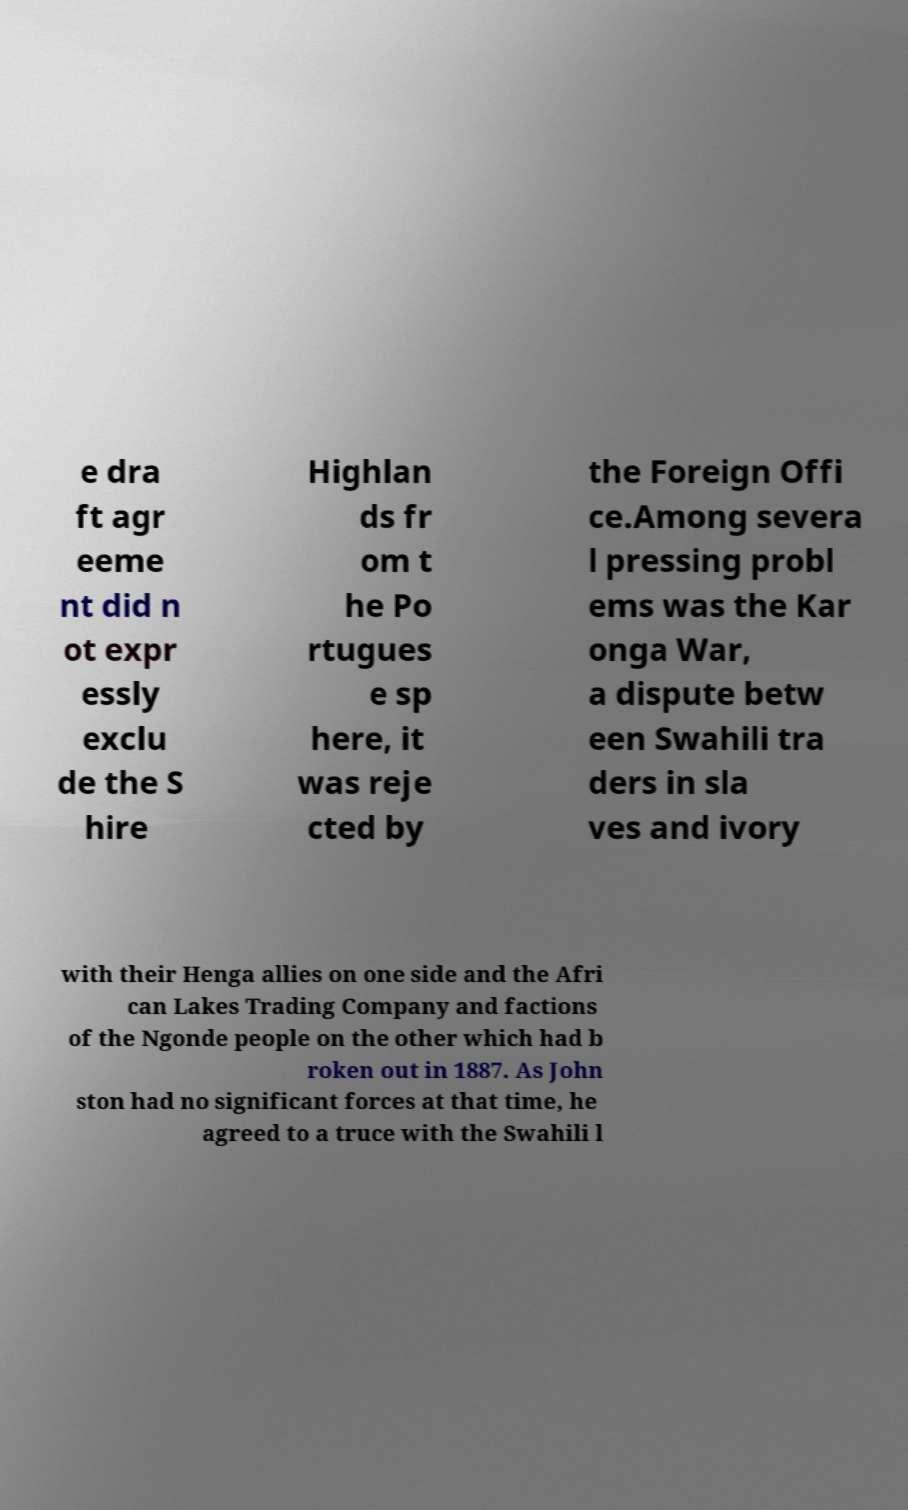What messages or text are displayed in this image? I need them in a readable, typed format. e dra ft agr eeme nt did n ot expr essly exclu de the S hire Highlan ds fr om t he Po rtugues e sp here, it was reje cted by the Foreign Offi ce.Among severa l pressing probl ems was the Kar onga War, a dispute betw een Swahili tra ders in sla ves and ivory with their Henga allies on one side and the Afri can Lakes Trading Company and factions of the Ngonde people on the other which had b roken out in 1887. As John ston had no significant forces at that time, he agreed to a truce with the Swahili l 